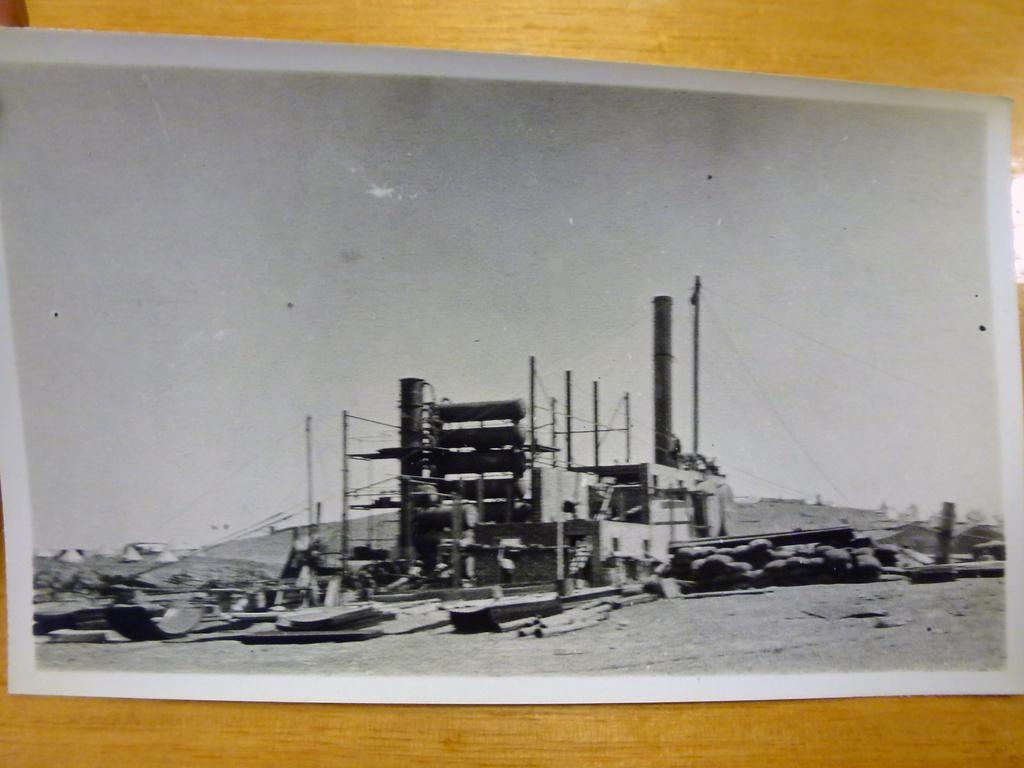Can you describe this image briefly? In this image there is a photograph on a wooden surface. In the photograph there are machines on the ground. It is a black and white picture. At the top of the picture there is the sky. In the background there are mountains. 